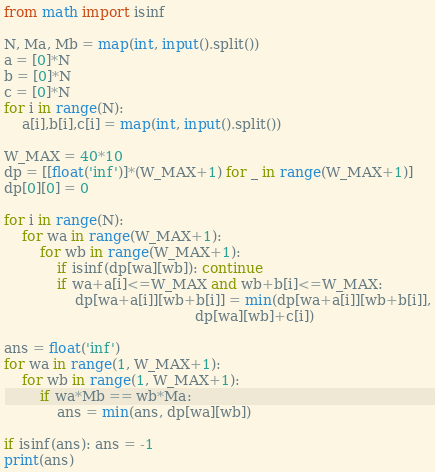<code> <loc_0><loc_0><loc_500><loc_500><_Python_>from math import isinf

N, Ma, Mb = map(int, input().split())
a = [0]*N
b = [0]*N
c = [0]*N
for i in range(N):
    a[i],b[i],c[i] = map(int, input().split())

W_MAX = 40*10
dp = [[float('inf')]*(W_MAX+1) for _ in range(W_MAX+1)]
dp[0][0] = 0

for i in range(N):
    for wa in range(W_MAX+1):
        for wb in range(W_MAX+1):
            if isinf(dp[wa][wb]): continue
            if wa+a[i]<=W_MAX and wb+b[i]<=W_MAX:
                dp[wa+a[i]][wb+b[i]] = min(dp[wa+a[i]][wb+b[i]],
                                           dp[wa][wb]+c[i])

ans = float('inf')
for wa in range(1, W_MAX+1):
    for wb in range(1, W_MAX+1):
        if wa*Mb == wb*Ma:
            ans = min(ans, dp[wa][wb])

if isinf(ans): ans = -1
print(ans)</code> 